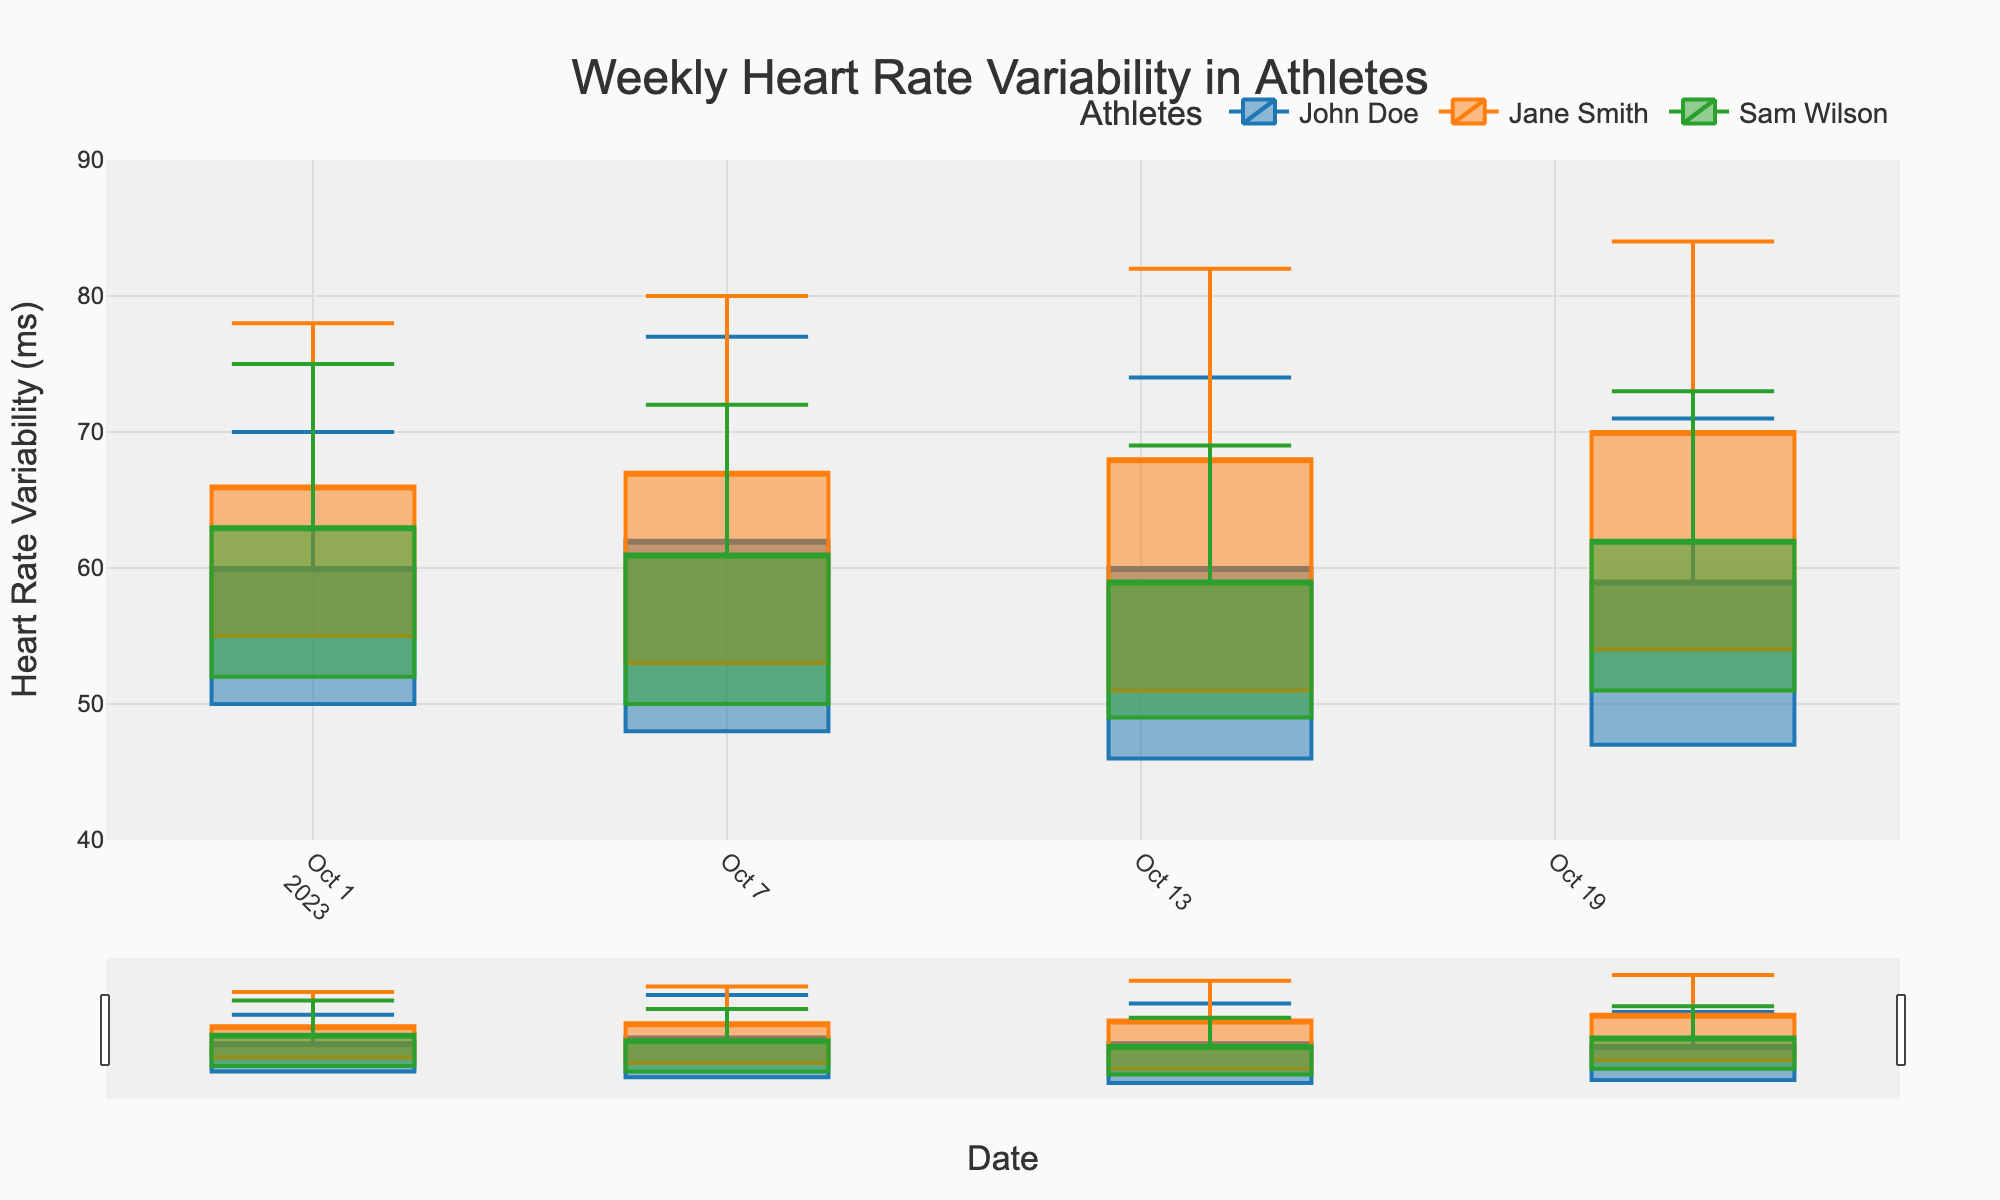What's the title of the figure? The title of the figure is displayed prominently at the top. It reads, 'Weekly Heart Rate Variability in Athletes’.
Answer: Weekly Heart Rate Variability in Athletes What are the ranges of heart rate variability (HRV) on the y-axis? The y-axis displays the range of heart rate variability measurements. It starts from 40 milliseconds and goes up to 90 milliseconds.
Answer: 40 to 90 milliseconds How many athletes are tracked in the figure? The legend at the top of the figure lists the athletes' names, using different colors for each. There are three athletes: John Doe, Jane Smith, and Sam Wilson.
Answer: Three athletes What week has the highest maximum HRV for Jane Smith? Reviewing the candlesticks for Jane Smith, the week with the highest top of the candlestick (maximum HRV) is the week of October 21 with a max HRV of 84 ms.
Answer: Week of October 21 Which athlete has the largest increase in average HRV from October 1 to October 7? To determine the increase, calculate the difference in average HRV from October 1 to October 7 for each athlete. John Doe: 62-60=2, Jane Smith: 67-66=1, Sam Wilson: 61-63=-2. John Doe shows the largest increase by 2 ms.
Answer: John Doe What is the trend for John Doe's minimum HRV over the weeks? By looking at the bottom of the candlesticks for John Doe, we see the HRV decreases over time: from 50 on October 1 to 48, 46, and finally to 47 by October 21. The general trend is a decrease.
Answer: Decrease On the week of October 14, which athlete has the smallest difference between their maximum and minimum HRV values? Calculate the difference for each athlete on October 14: John Doe: 74-46=28, Jane Smith: 82-51=31, Sam Wilson: 69-49=20. Sam Wilson has the smallest difference.
Answer: Sam Wilson What can be inferred about Sam Wilson’s training cycle from his HRV measurements over the weeks? Observing Sam Wilson's HRV measurements: minimum values decrease over time (52 to 50 to 49), maximum values generally decrease with minor fluctuation (75 to 72 to 69), and average HRV generally drops (63 to 61 to 59). This suggests an increasing training load causing more physiological stress.
Answer: Increasing training load Which week had John's highest recorded average HRV? By examining the closing part of the candlesticks for John Doe, the highest average HRV is observed on the week of October 7 with a value of 62 ms.
Answer: Week of October 7 